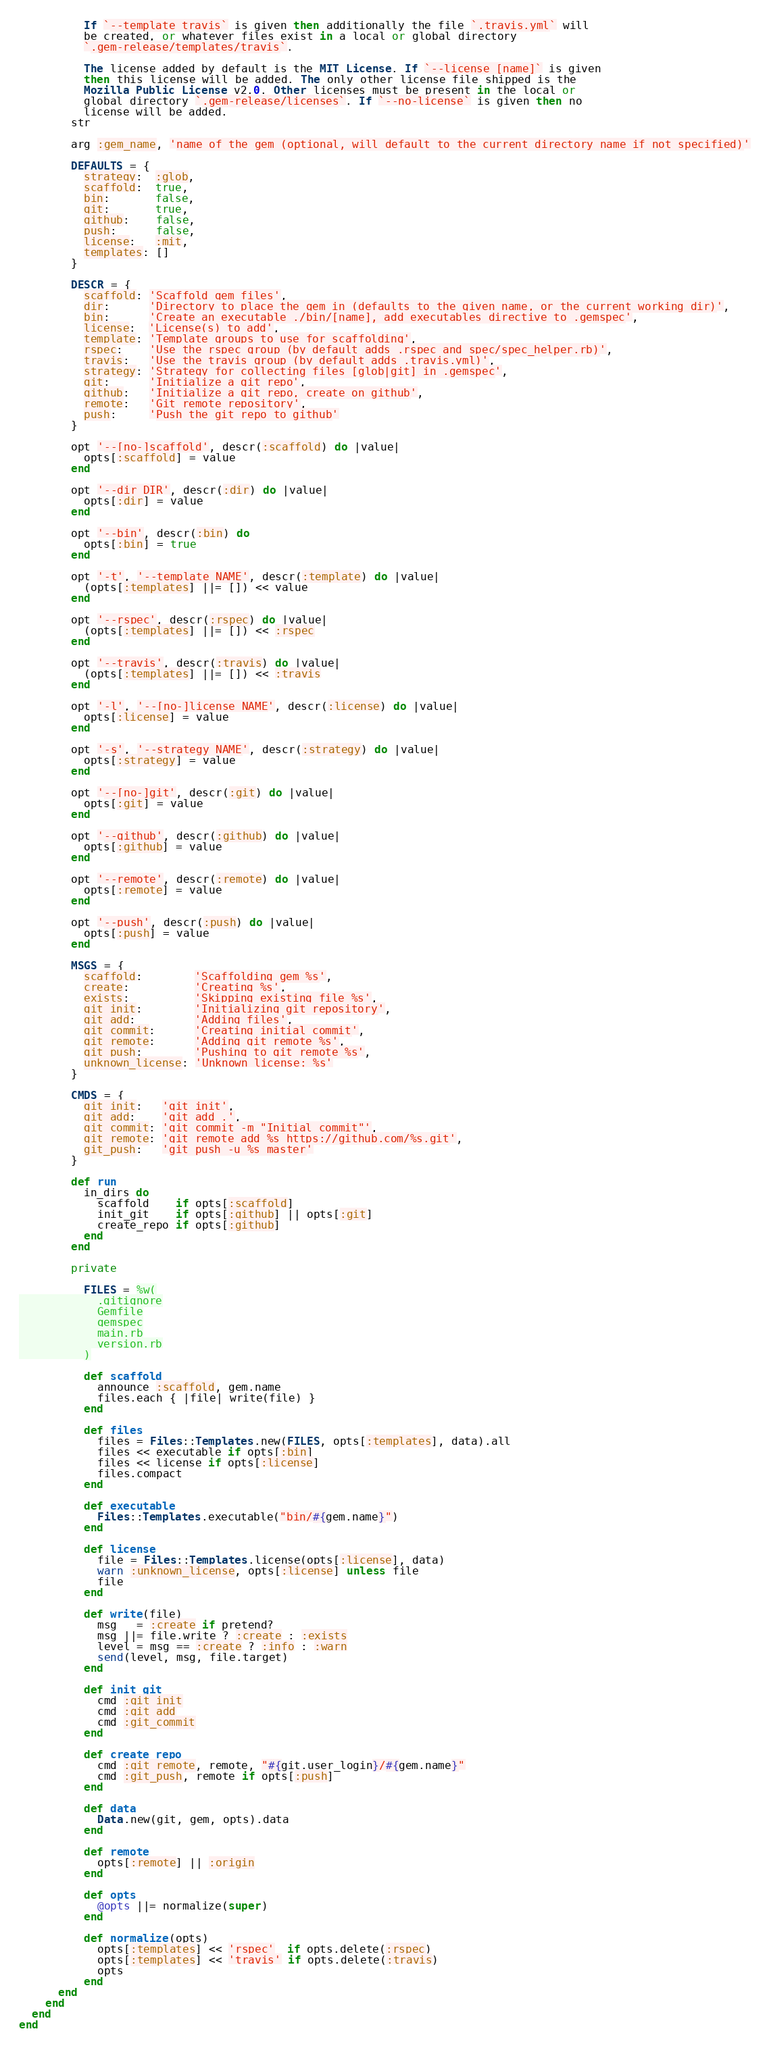Convert code to text. <code><loc_0><loc_0><loc_500><loc_500><_Ruby_>          If `--template travis` is given then additionally the file `.travis.yml` will
          be created, or whatever files exist in a local or global directory
          `.gem-release/templates/travis`.

          The license added by default is the MIT License. If `--license [name]` is given
          then this license will be added. The only other license file shipped is the
          Mozilla Public License v2.0. Other licenses must be present in the local or
          global directory `.gem-release/licenses`. If `--no-license` is given then no
          license will be added.
        str

        arg :gem_name, 'name of the gem (optional, will default to the current directory name if not specified)'

        DEFAULTS = {
          strategy:  :glob,
          scaffold:  true,
          bin:       false,
          git:       true,
          github:    false,
          push:      false,
          license:   :mit,
          templates: []
        }

        DESCR = {
          scaffold: 'Scaffold gem files',
          dir:      'Directory to place the gem in (defaults to the given name, or the current working dir)',
          bin:      'Create an executable ./bin/[name], add executables directive to .gemspec',
          license:  'License(s) to add',
          template: 'Template groups to use for scaffolding',
          rspec:    'Use the rspec group (by default adds .rspec and spec/spec_helper.rb)',
          travis:   'Use the travis group (by default adds .travis.yml)',
          strategy: 'Strategy for collecting files [glob|git] in .gemspec',
          git:      'Initialize a git repo',
          github:   'Initialize a git repo, create on github',
          remote:   'Git remote repository',
          push:     'Push the git repo to github'
        }

        opt '--[no-]scaffold', descr(:scaffold) do |value|
          opts[:scaffold] = value
        end

        opt '--dir DIR', descr(:dir) do |value|
          opts[:dir] = value
        end

        opt '--bin', descr(:bin) do
          opts[:bin] = true
        end

        opt '-t', '--template NAME', descr(:template) do |value|
          (opts[:templates] ||= []) << value
        end

        opt '--rspec', descr(:rspec) do |value|
          (opts[:templates] ||= []) << :rspec
        end

        opt '--travis', descr(:travis) do |value|
          (opts[:templates] ||= []) << :travis
        end

        opt '-l', '--[no-]license NAME', descr(:license) do |value|
          opts[:license] = value
        end

        opt '-s', '--strategy NAME', descr(:strategy) do |value|
          opts[:strategy] = value
        end

        opt '--[no-]git', descr(:git) do |value|
          opts[:git] = value
        end

        opt '--github', descr(:github) do |value|
          opts[:github] = value
        end

        opt '--remote', descr(:remote) do |value|
          opts[:remote] = value
        end

        opt '--push', descr(:push) do |value|
          opts[:push] = value
        end

        MSGS = {
          scaffold:        'Scaffolding gem %s',
          create:          'Creating %s',
          exists:          'Skipping existing file %s',
          git_init:        'Initializing git repository',
          git_add:         'Adding files',
          git_commit:      'Creating initial commit',
          git_remote:      'Adding git remote %s',
          git_push:        'Pushing to git remote %s',
          unknown_license: 'Unknown license: %s'
        }

        CMDS = {
          git_init:   'git init',
          git_add:    'git add .',
          git_commit: 'git commit -m "Initial commit"',
          git_remote: 'git remote add %s https://github.com/%s.git',
          git_push:   'git push -u %s master'
        }

        def run
          in_dirs do
            scaffold    if opts[:scaffold]
            init_git    if opts[:github] || opts[:git]
            create_repo if opts[:github]
          end
        end

        private

          FILES = %w(
            .gitignore
            Gemfile
            gemspec
            main.rb
            version.rb
          )

          def scaffold
            announce :scaffold, gem.name
            files.each { |file| write(file) }
          end

          def files
            files = Files::Templates.new(FILES, opts[:templates], data).all
            files << executable if opts[:bin]
            files << license if opts[:license]
            files.compact
          end

          def executable
            Files::Templates.executable("bin/#{gem.name}")
          end

          def license
            file = Files::Templates.license(opts[:license], data)
            warn :unknown_license, opts[:license] unless file
            file
          end

          def write(file)
            msg   = :create if pretend?
            msg ||= file.write ? :create : :exists
            level = msg == :create ? :info : :warn
            send(level, msg, file.target)
          end

          def init_git
            cmd :git_init
            cmd :git_add
            cmd :git_commit
          end

          def create_repo
            cmd :git_remote, remote, "#{git.user_login}/#{gem.name}"
            cmd :git_push, remote if opts[:push]
          end

          def data
            Data.new(git, gem, opts).data
          end

          def remote
            opts[:remote] || :origin
          end

          def opts
            @opts ||= normalize(super)
          end

          def normalize(opts)
            opts[:templates] << 'rspec'  if opts.delete(:rspec)
            opts[:templates] << 'travis' if opts.delete(:travis)
            opts
          end
      end
    end
  end
end
</code> 